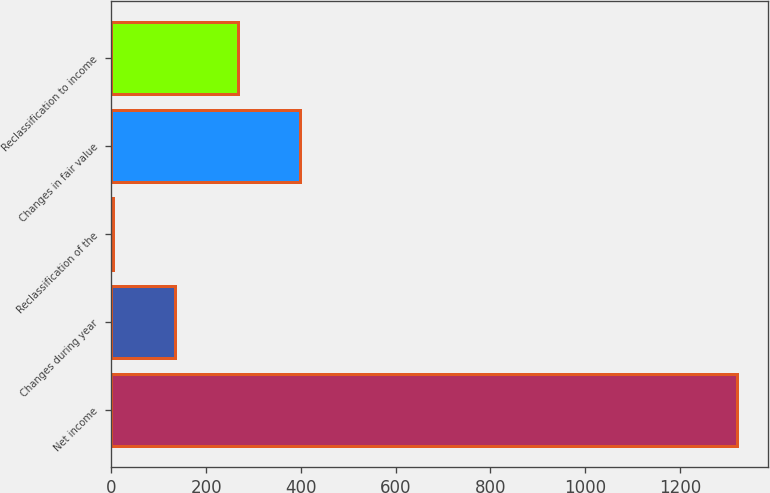<chart> <loc_0><loc_0><loc_500><loc_500><bar_chart><fcel>Net income<fcel>Changes during year<fcel>Reclassification of the<fcel>Changes in fair value<fcel>Reclassification to income<nl><fcel>1321<fcel>134.8<fcel>3<fcel>398.4<fcel>266.6<nl></chart> 